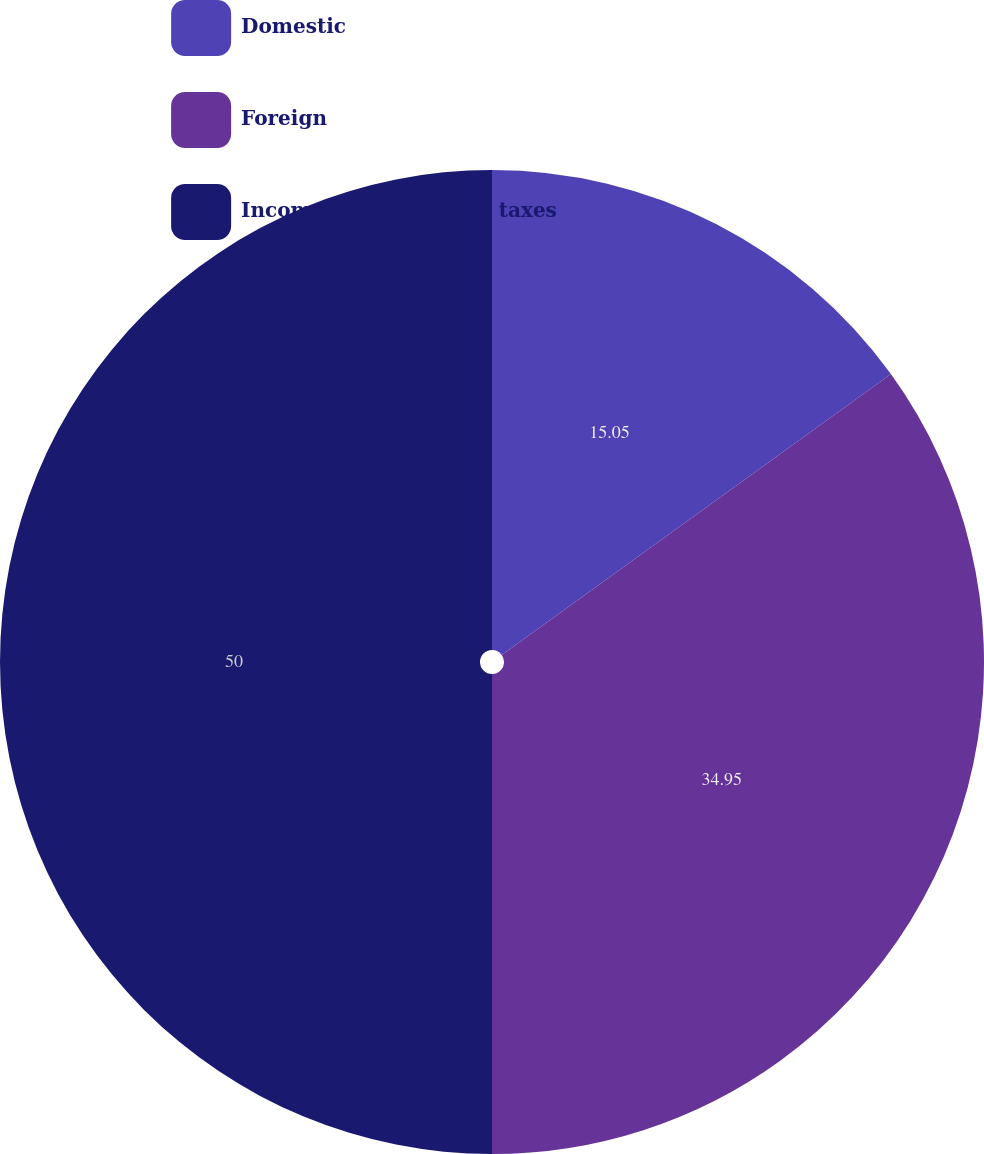<chart> <loc_0><loc_0><loc_500><loc_500><pie_chart><fcel>Domestic<fcel>Foreign<fcel>Income before income taxes<nl><fcel>15.05%<fcel>34.95%<fcel>50.0%<nl></chart> 